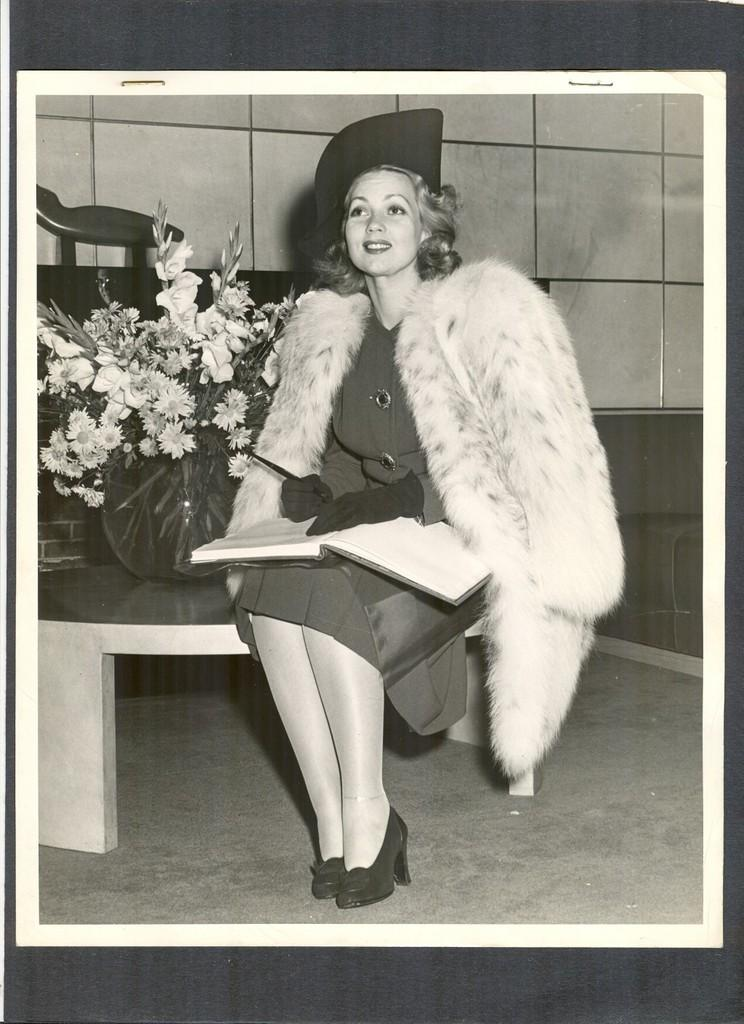What is the main subject of the image? The main subject of the image is a black and white photocopy of a lady. What is the lady holding in the image? The lady is holding an object in the image. What is the lady's posture in the image? The lady is sitting in the image. What type of vegetation can be seen in the image? There are flowers in the image. What else is present in the image besides the lady and flowers? There is an object and a wall in the image. What can be seen beneath the lady in the image? The ground is visible in the image. What type of business is being conducted on the sidewalk in the image? There is no sidewalk present in the image, and no business activity is depicted. 